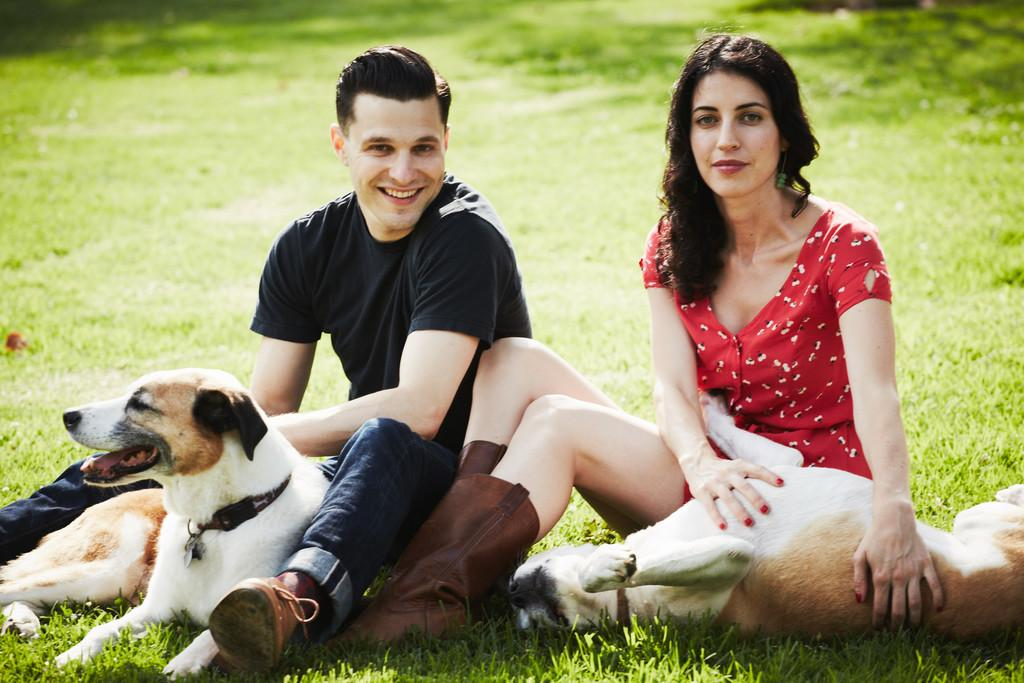How many people are in the image? There are two persons in the image. What are the persons doing in the image? The persons are sitting and smiling. What are the persons holding in the image? The persons are holding dogs. What type of surface can be seen in the image? There is grass in the image. Can you tell me how many cows are present in the image? There are no cows present in the image; it features two persons holding dogs. What type of wind instrument is being played in the image? There is no wind instrument being played in the image; the persons are holding dogs and sitting on grass. 